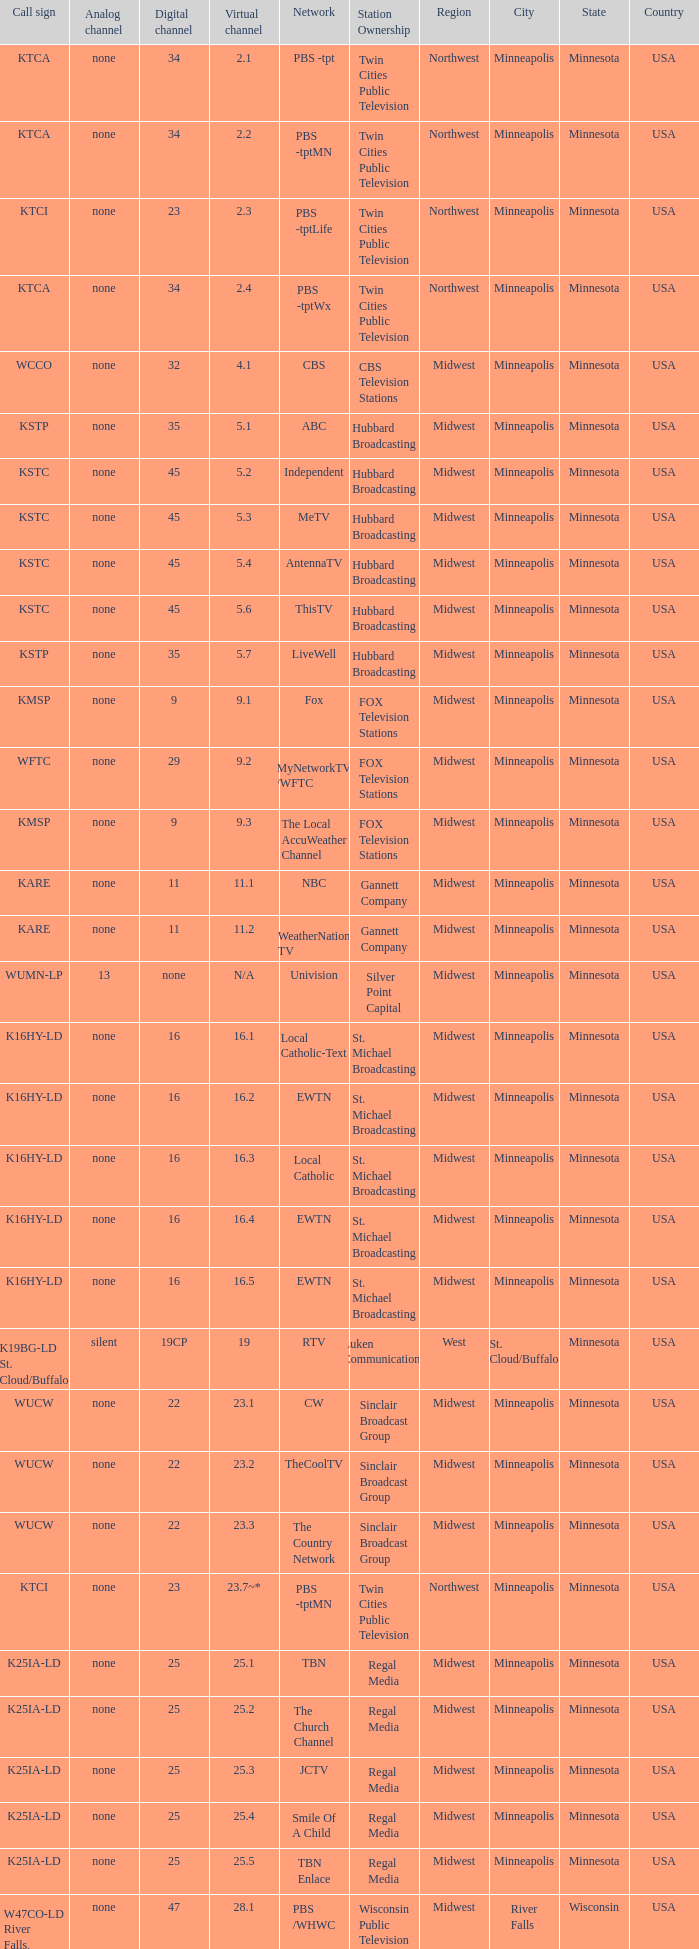Network of nbc is what digital channel? 11.0. 